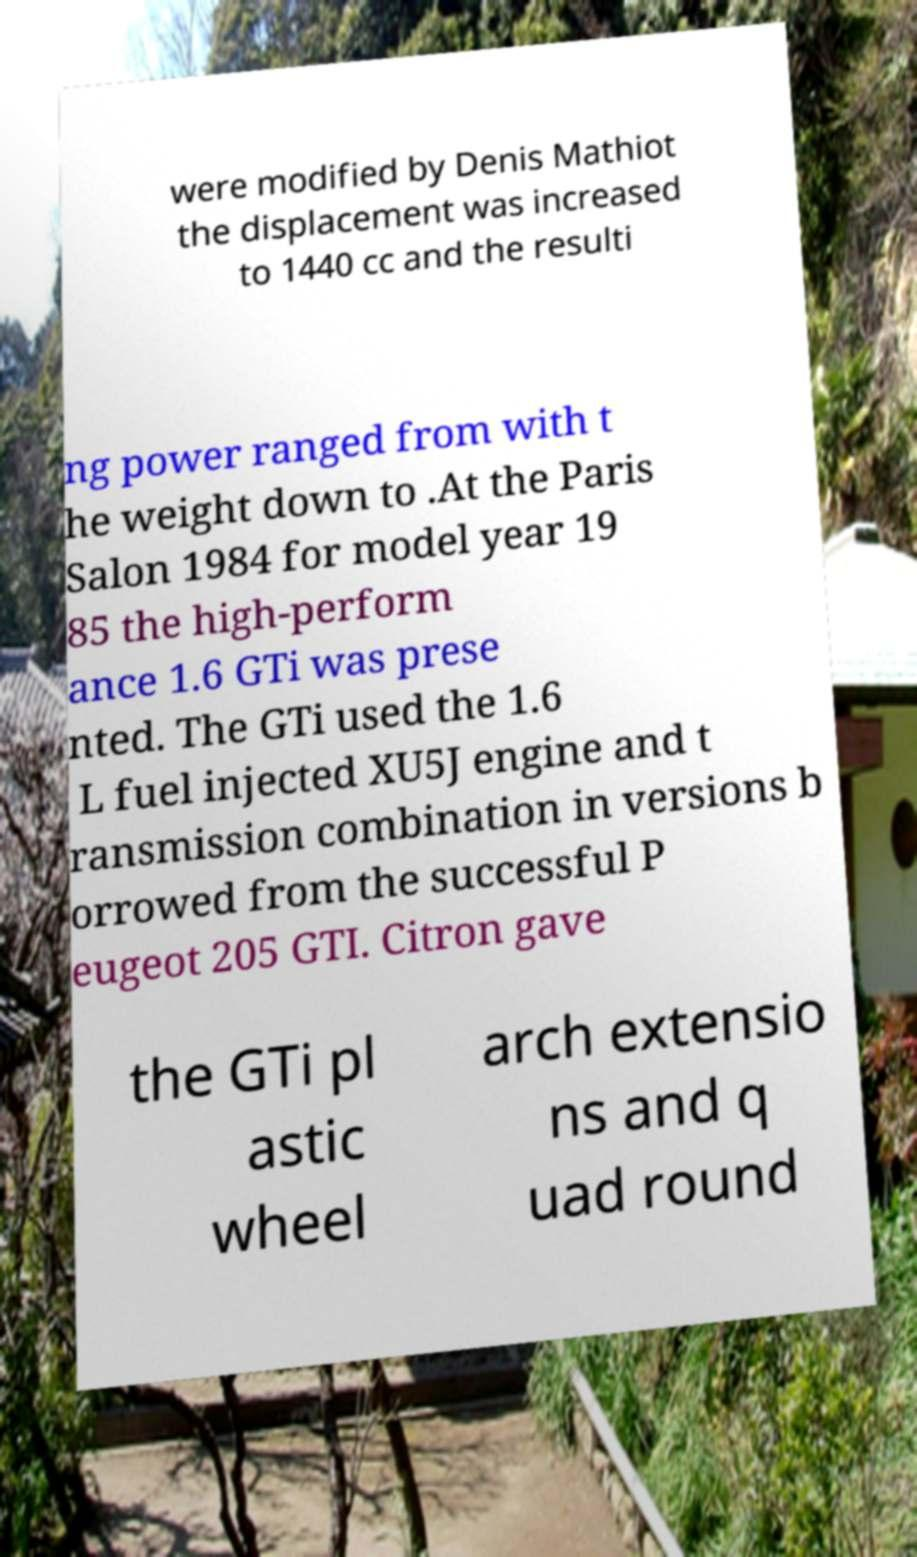Please read and relay the text visible in this image. What does it say? were modified by Denis Mathiot the displacement was increased to 1440 cc and the resulti ng power ranged from with t he weight down to .At the Paris Salon 1984 for model year 19 85 the high-perform ance 1.6 GTi was prese nted. The GTi used the 1.6 L fuel injected XU5J engine and t ransmission combination in versions b orrowed from the successful P eugeot 205 GTI. Citron gave the GTi pl astic wheel arch extensio ns and q uad round 